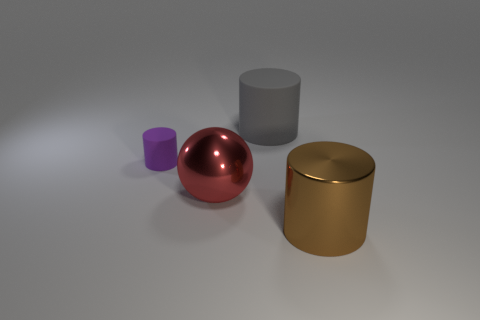Could the image be used to explain certain physics concepts? Yes, this image could serve as a visual aid for discussing concepts such as reflection and surface properties, the interaction of light with different materials, or even basic geometry and spatial relationships between objects. 